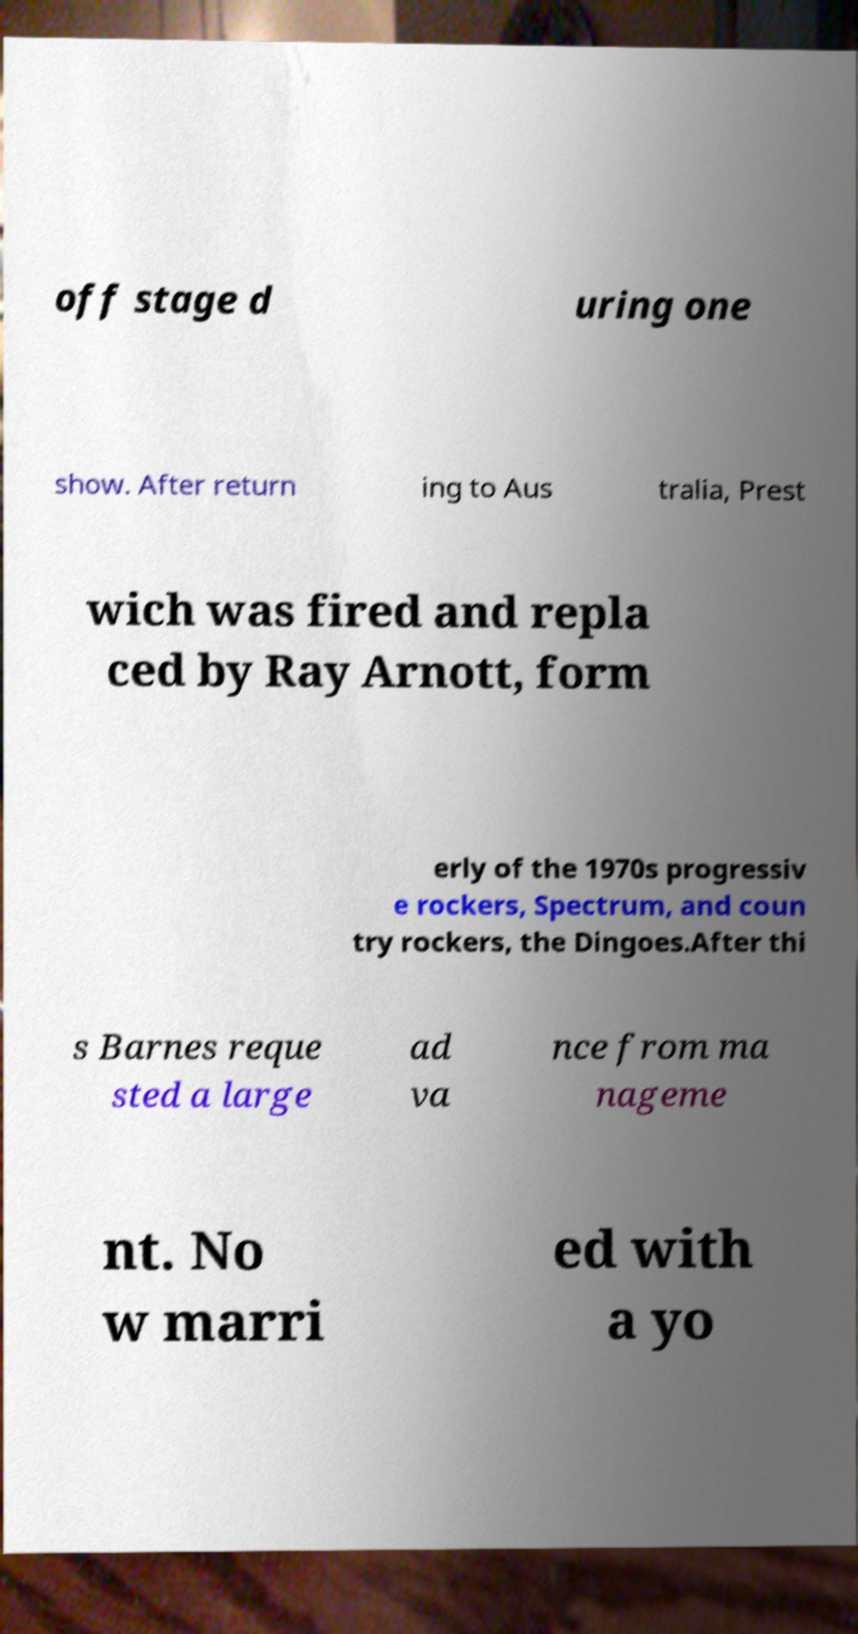Please identify and transcribe the text found in this image. off stage d uring one show. After return ing to Aus tralia, Prest wich was fired and repla ced by Ray Arnott, form erly of the 1970s progressiv e rockers, Spectrum, and coun try rockers, the Dingoes.After thi s Barnes reque sted a large ad va nce from ma nageme nt. No w marri ed with a yo 